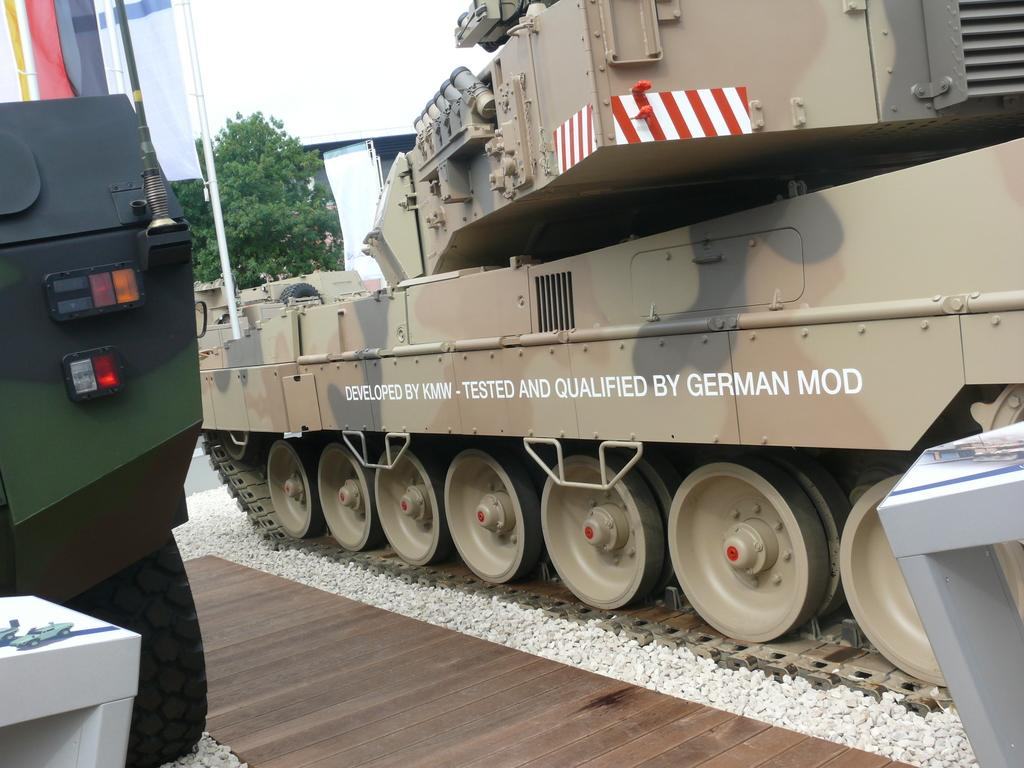What type of vehicles are in the foreground of the image? There are army vehicles in the foreground of the image. What can be seen in the background of the image? There is a tree and the sky visible in the background of the image. What color is the balloon floating above the army vehicles in the image? There is no balloon present in the image. What type of cap is the soldier wearing in the image? There are no soldiers or caps visible in the image. 